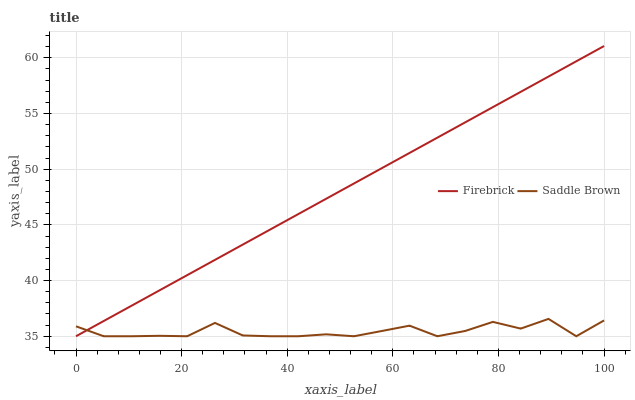Does Saddle Brown have the minimum area under the curve?
Answer yes or no. Yes. Does Firebrick have the maximum area under the curve?
Answer yes or no. Yes. Does Saddle Brown have the maximum area under the curve?
Answer yes or no. No. Is Firebrick the smoothest?
Answer yes or no. Yes. Is Saddle Brown the roughest?
Answer yes or no. Yes. Is Saddle Brown the smoothest?
Answer yes or no. No. Does Firebrick have the lowest value?
Answer yes or no. Yes. Does Firebrick have the highest value?
Answer yes or no. Yes. Does Saddle Brown have the highest value?
Answer yes or no. No. Does Saddle Brown intersect Firebrick?
Answer yes or no. Yes. Is Saddle Brown less than Firebrick?
Answer yes or no. No. Is Saddle Brown greater than Firebrick?
Answer yes or no. No. 